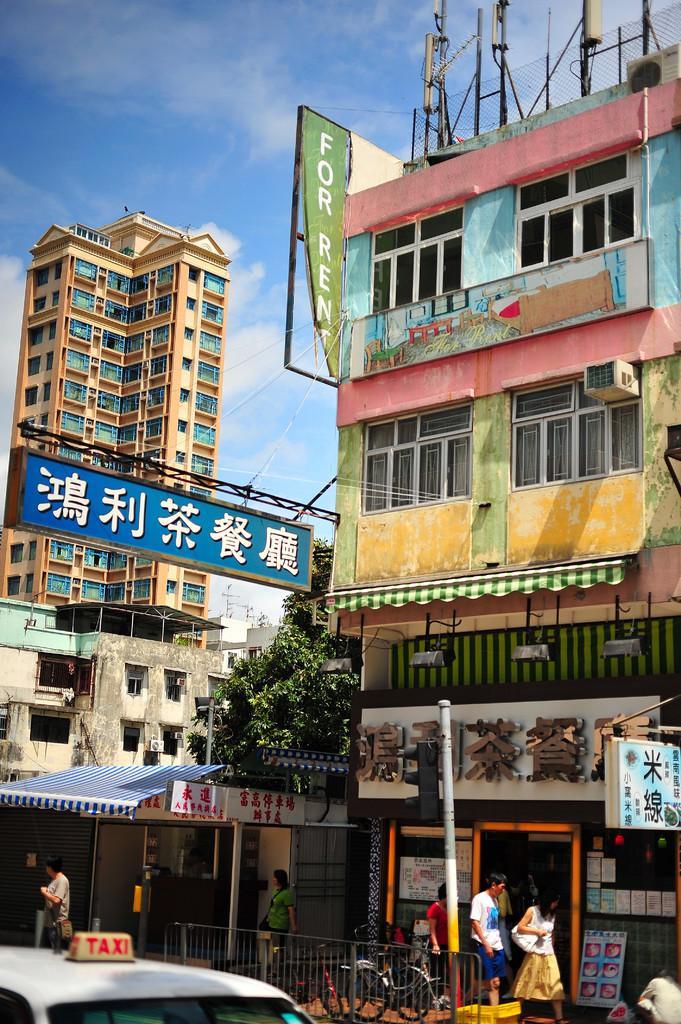Please provide a concise description of this image. In this image we can see there are buildings and there are boards attached to the building. In front of the building there are people walking and there are vehicles. There are trees, poles, fence and the sky. 